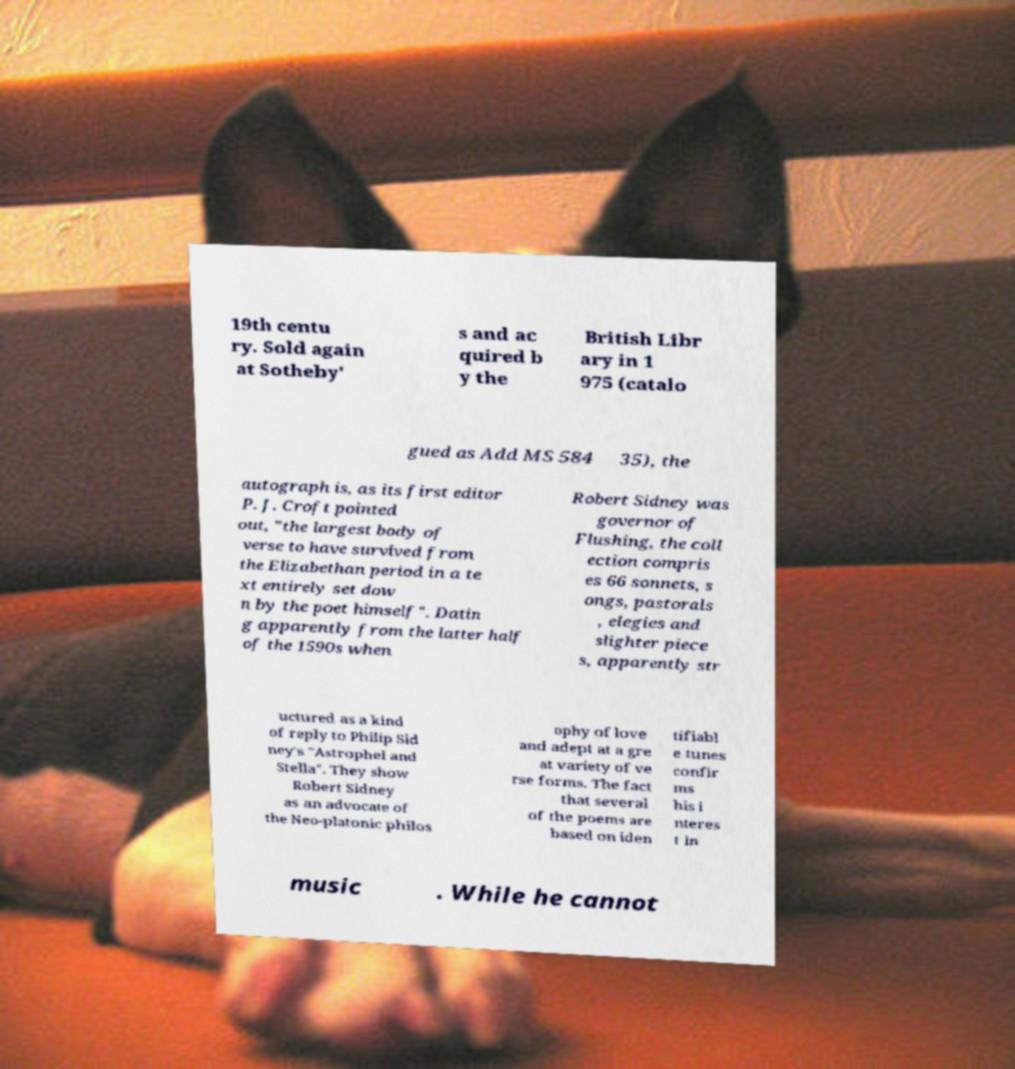Can you accurately transcribe the text from the provided image for me? 19th centu ry. Sold again at Sotheby' s and ac quired b y the British Libr ary in 1 975 (catalo gued as Add MS 584 35), the autograph is, as its first editor P. J. Croft pointed out, "the largest body of verse to have survived from the Elizabethan period in a te xt entirely set dow n by the poet himself". Datin g apparently from the latter half of the 1590s when Robert Sidney was governor of Flushing, the coll ection compris es 66 sonnets, s ongs, pastorals , elegies and slighter piece s, apparently str uctured as a kind of reply to Philip Sid ney's "Astrophel and Stella". They show Robert Sidney as an advocate of the Neo-platonic philos ophy of love and adept at a gre at variety of ve rse forms. The fact that several of the poems are based on iden tifiabl e tunes confir ms his i nteres t in music . While he cannot 